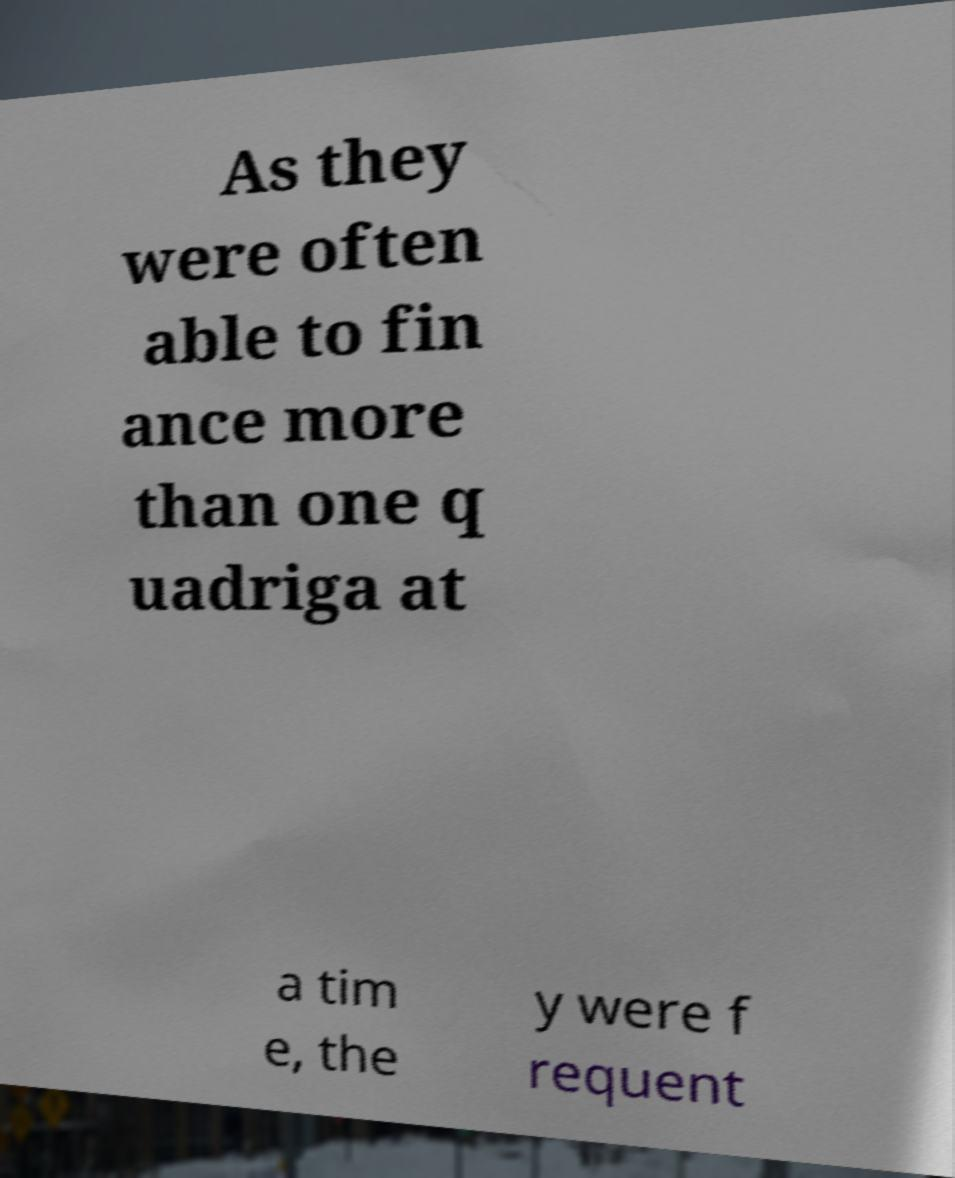Please read and relay the text visible in this image. What does it say? As they were often able to fin ance more than one q uadriga at a tim e, the y were f requent 